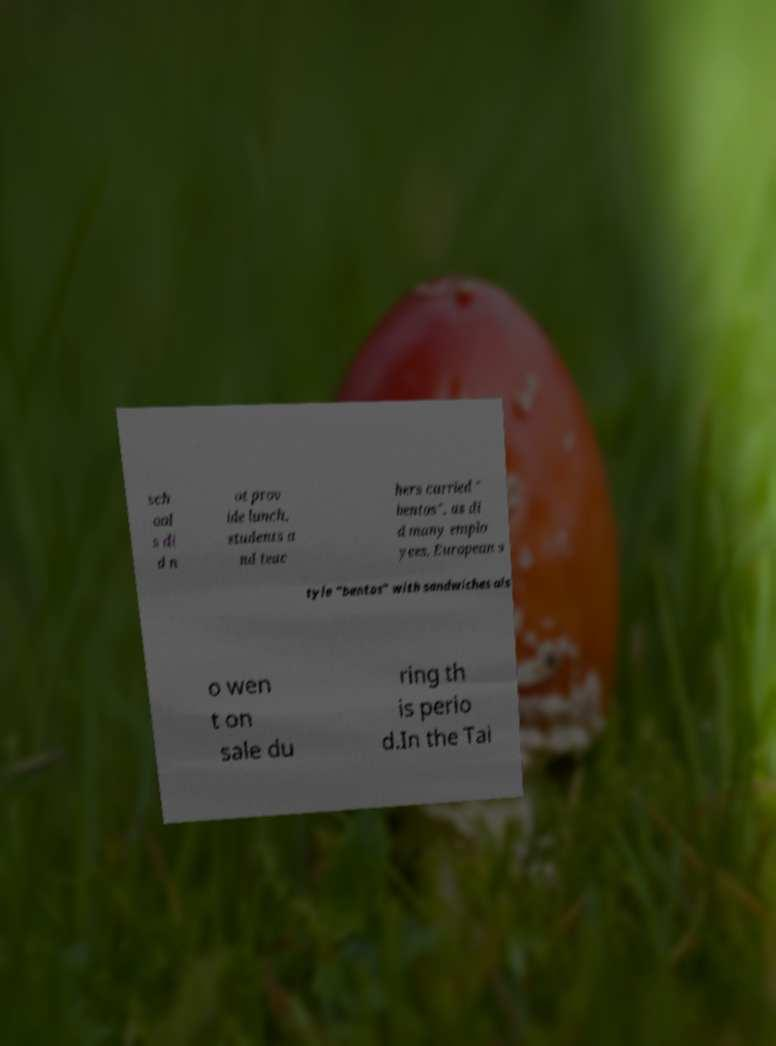What messages or text are displayed in this image? I need them in a readable, typed format. sch ool s di d n ot prov ide lunch, students a nd teac hers carried " bentos", as di d many emplo yees. European s tyle "bentos" with sandwiches als o wen t on sale du ring th is perio d.In the Tai 